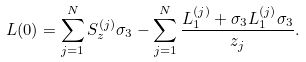Convert formula to latex. <formula><loc_0><loc_0><loc_500><loc_500>L ( 0 ) = \sum _ { j = 1 } ^ { N } S _ { z } ^ { ( j ) } \sigma _ { 3 } - \sum _ { j = 1 } ^ { N } \frac { L _ { 1 } ^ { ( j ) } + \sigma _ { 3 } L _ { 1 } ^ { ( j ) } \sigma _ { 3 } } { z _ { j } } .</formula> 